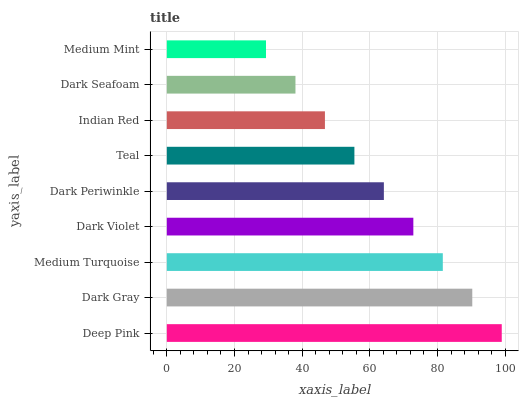Is Medium Mint the minimum?
Answer yes or no. Yes. Is Deep Pink the maximum?
Answer yes or no. Yes. Is Dark Gray the minimum?
Answer yes or no. No. Is Dark Gray the maximum?
Answer yes or no. No. Is Deep Pink greater than Dark Gray?
Answer yes or no. Yes. Is Dark Gray less than Deep Pink?
Answer yes or no. Yes. Is Dark Gray greater than Deep Pink?
Answer yes or no. No. Is Deep Pink less than Dark Gray?
Answer yes or no. No. Is Dark Periwinkle the high median?
Answer yes or no. Yes. Is Dark Periwinkle the low median?
Answer yes or no. Yes. Is Teal the high median?
Answer yes or no. No. Is Dark Seafoam the low median?
Answer yes or no. No. 